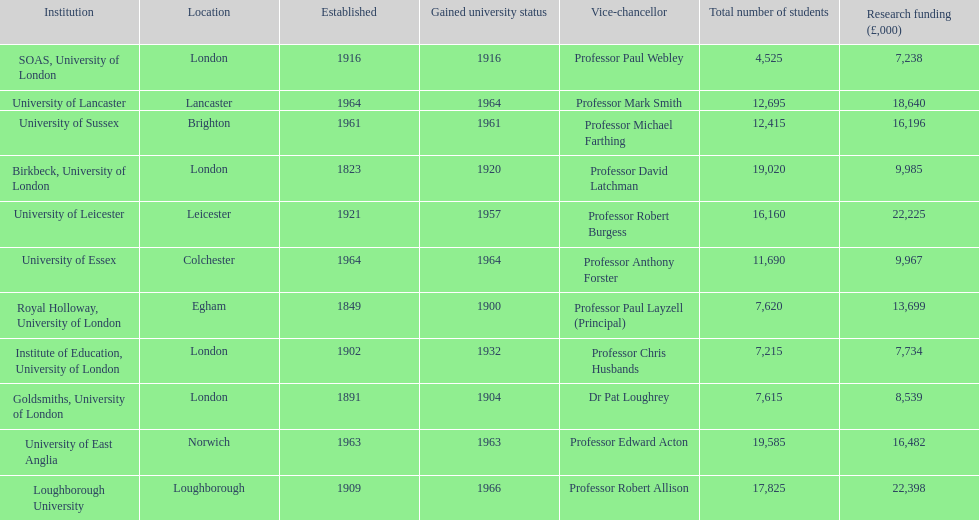How many of the institutions are located in london? 4. 